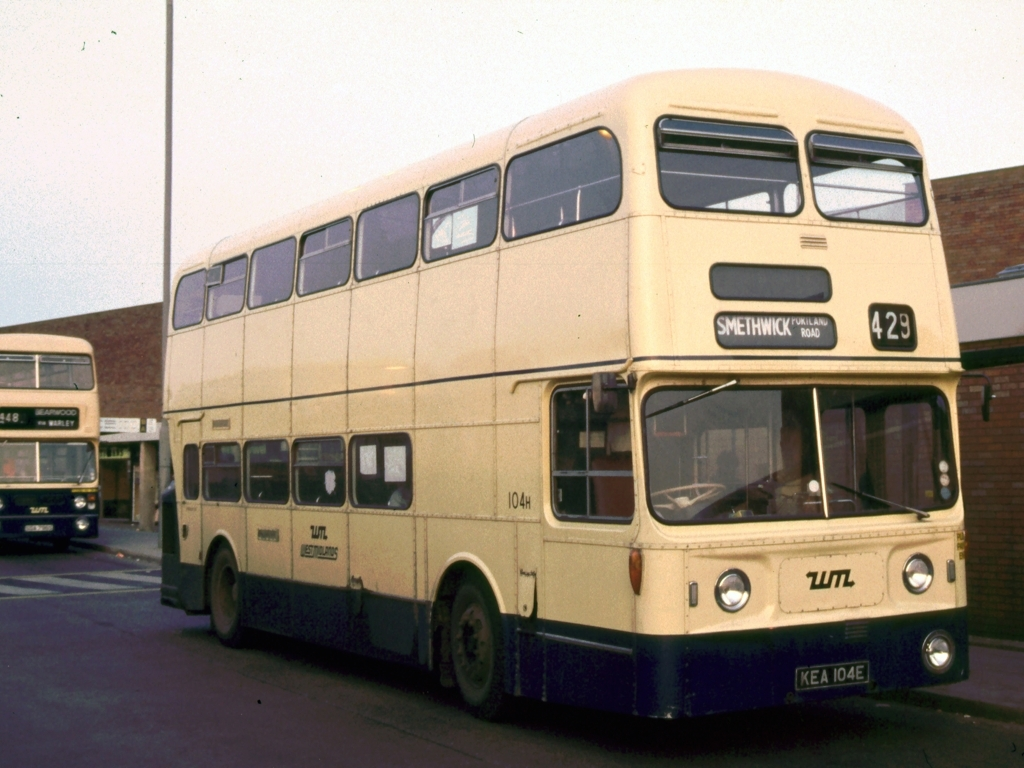What era does this bus come from? The bus in the image has a design that suggests it originates from the mid-20th century, possibly from the 1960s or 1970s, based on its boxy structure and the style of the text on the side. 